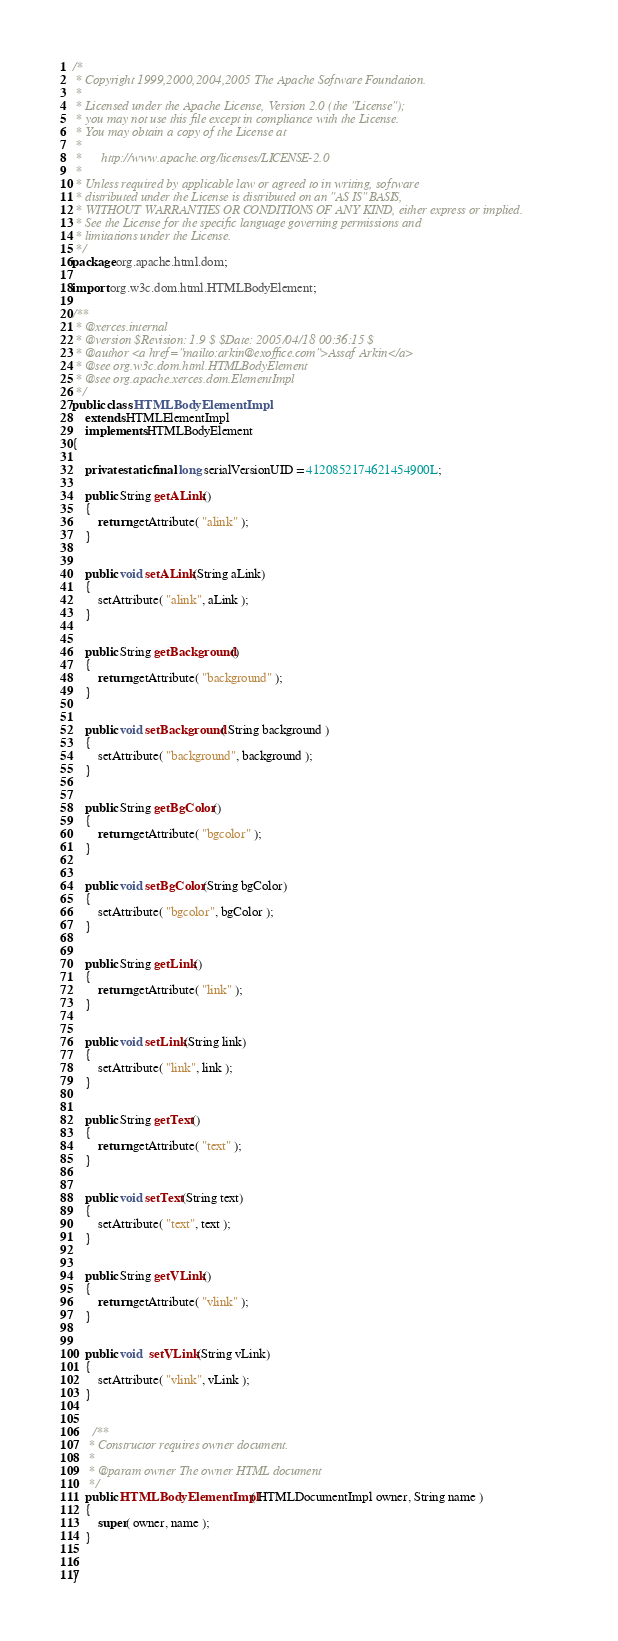Convert code to text. <code><loc_0><loc_0><loc_500><loc_500><_Java_>/*
 * Copyright 1999,2000,2004,2005 The Apache Software Foundation.
 * 
 * Licensed under the Apache License, Version 2.0 (the "License");
 * you may not use this file except in compliance with the License.
 * You may obtain a copy of the License at
 * 
 *      http://www.apache.org/licenses/LICENSE-2.0
 * 
 * Unless required by applicable law or agreed to in writing, software
 * distributed under the License is distributed on an "AS IS" BASIS,
 * WITHOUT WARRANTIES OR CONDITIONS OF ANY KIND, either express or implied.
 * See the License for the specific language governing permissions and
 * limitations under the License.
 */
package org.apache.html.dom;

import org.w3c.dom.html.HTMLBodyElement;

/**
 * @xerces.internal
 * @version $Revision: 1.9 $ $Date: 2005/04/18 00:36:15 $
 * @author <a href="mailto:arkin@exoffice.com">Assaf Arkin</a>
 * @see org.w3c.dom.html.HTMLBodyElement
 * @see org.apache.xerces.dom.ElementImpl
 */
public class HTMLBodyElementImpl
    extends HTMLElementImpl
    implements HTMLBodyElement
{
    
    private static final long serialVersionUID = 4120852174621454900L;

    public String getALink()
    {
        return getAttribute( "alink" );
    }

    
    public void setALink(String aLink)
    {
        setAttribute( "alink", aLink );
    }
    
  
    public String getBackground()
    {
        return getAttribute( "background" );
    }
    
  
    public void setBackground( String background )
    {
        setAttribute( "background", background );
    }
    
  
    public String getBgColor()
    {
        return getAttribute( "bgcolor" );
    }
    
    
    public void setBgColor(String bgColor)
    {
        setAttribute( "bgcolor", bgColor );
    }
    
  
    public String getLink()
    {
        return getAttribute( "link" );
    }
  
    
    public void setLink(String link)
    {
        setAttribute( "link", link );
    }
    
  
    public String getText()
    {
        return getAttribute( "text" );
    }
    
  
    public void setText(String text)
    {
        setAttribute( "text", text );
    }
    
  
    public String getVLink()
    {
        return getAttribute( "vlink" );
    }
  
    
    public void  setVLink(String vLink)
    {
        setAttribute( "vlink", vLink );
    }
  
    
      /**
     * Constructor requires owner document.
     * 
     * @param owner The owner HTML document
     */
    public HTMLBodyElementImpl( HTMLDocumentImpl owner, String name )
    {
        super( owner, name );
    }

  
}

</code> 